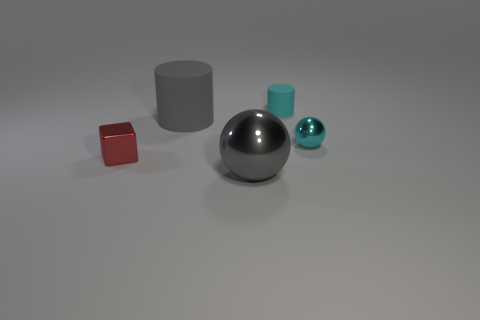How many large gray metallic objects are left of the matte cylinder that is on the right side of the large object behind the gray ball?
Your response must be concise. 1. There is a tiny shiny thing that is on the right side of the cylinder that is left of the small cyan rubber cylinder; what shape is it?
Offer a terse response. Sphere. What is the size of the other thing that is the same shape as the big gray metal object?
Offer a very short reply. Small. Are there any other things that are the same size as the cyan metal ball?
Provide a short and direct response. Yes. The shiny sphere that is right of the small rubber object is what color?
Your answer should be very brief. Cyan. The thing on the left side of the matte object in front of the cylinder that is behind the gray cylinder is made of what material?
Offer a terse response. Metal. There is a shiny ball right of the large gray thing that is in front of the red thing; what size is it?
Offer a very short reply. Small. What is the color of the other small matte object that is the same shape as the gray matte thing?
Your answer should be very brief. Cyan. How many large things are the same color as the small cube?
Ensure brevity in your answer.  0. Is the size of the red thing the same as the cyan matte cylinder?
Offer a very short reply. Yes. 